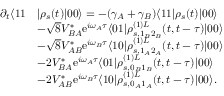Convert formula to latex. <formula><loc_0><loc_0><loc_500><loc_500>\begin{array} { r l } { \partial _ { t } \langle 1 1 } & { | \rho _ { s } ( t ) | 0 0 \rangle = - ( \gamma _ { A } + \gamma _ { B } ) \langle 1 1 | \rho _ { s } ( t ) | 0 0 \rangle } \\ & { - \sqrt { 8 } V _ { B A } ^ { * } e ^ { i \omega _ { A } \tau } \langle 0 1 | \rho _ { s , 1 _ { B } 2 _ { B } } ^ { ( 1 ) L } ( t , t - \tau ) | 0 0 \rangle } \\ & { - \sqrt { 8 } V _ { A B } ^ { * } e ^ { i \omega _ { B } \tau } \langle 1 0 | \rho _ { s , 1 _ { A } 2 _ { A } } ^ { ( 1 ) L } ( t , t - \tau ) | 0 0 \rangle } \\ & { - 2 V _ { B A } ^ { * } e ^ { i \omega _ { A } \tau } \langle 0 1 | \rho _ { s , 0 _ { B } 1 _ { B } } ^ { ( 1 ) L } ( t , t - \tau ) | 0 0 \rangle } \\ & { - 2 V _ { A B } ^ { * } e ^ { i \omega _ { B } \tau } \langle 1 0 | \rho _ { s , 0 _ { A } 1 _ { A } } ^ { ( 1 ) L } ( t , t - \tau ) | 0 0 \rangle . } \end{array}</formula> 